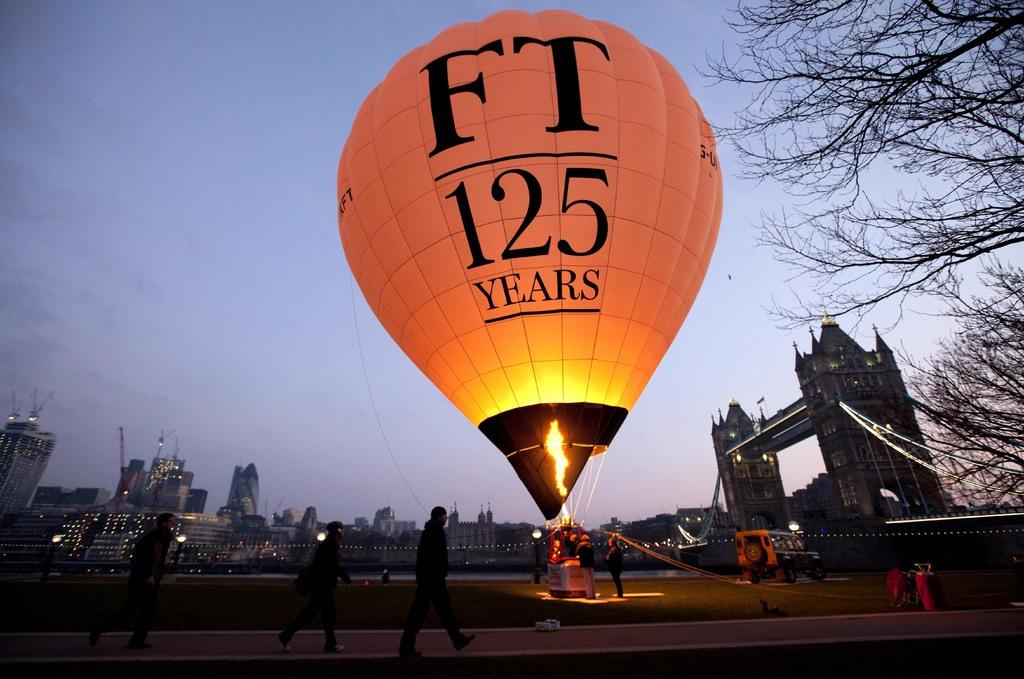<image>
Create a compact narrative representing the image presented. the numbers 125 that are on the hot air balloon 